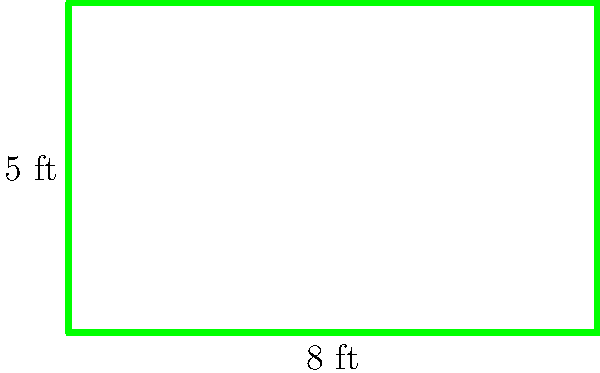On the set of your latest movie, you're working with a rectangular green screen. The green screen measures 8 feet in width and 5 feet in height. What is the total area of the green screen in square feet? To find the area of a rectangular green screen, we need to multiply its width by its height. Let's break it down step-by-step:

1. Identify the dimensions:
   - Width = 8 feet
   - Height = 5 feet

2. Use the formula for the area of a rectangle:
   $$ \text{Area} = \text{width} \times \text{height} $$

3. Plug in the values:
   $$ \text{Area} = 8 \text{ ft} \times 5 \text{ ft} $$

4. Multiply:
   $$ \text{Area} = 40 \text{ sq ft} $$

Therefore, the total area of the green screen is 40 square feet.
Answer: 40 sq ft 